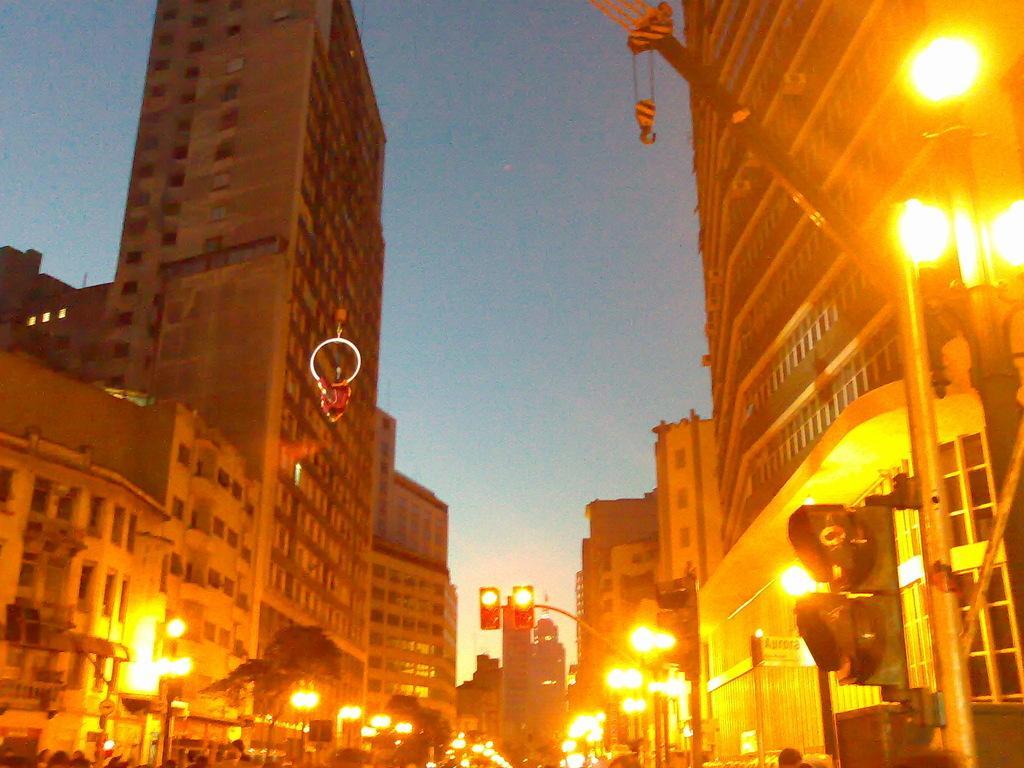Can you describe this image briefly? In this image I can see few persons standing, few lights, few poles, few traffic signals, a crane and few buildings on both sides of the road. In the background I can see the sky. 